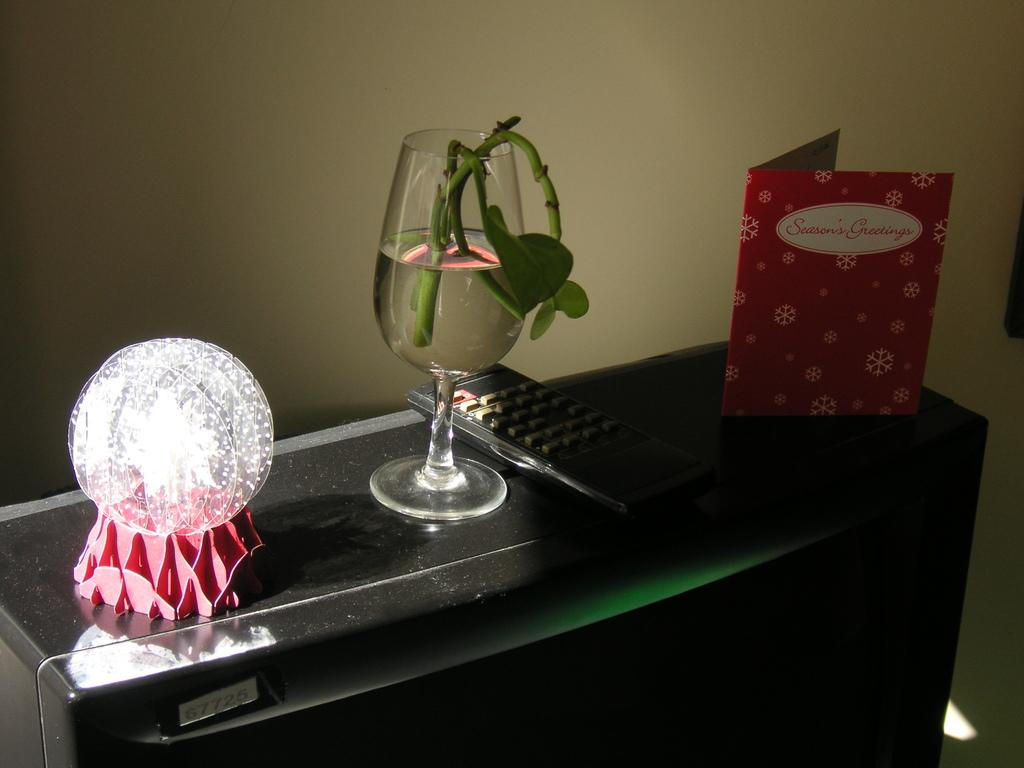What type of object is visible in the image that is typically used for drinking? There is a glass in the image. What object is visible in the image that is used for controlling electronic devices? There is a remote in the image. What type of object is visible in the image that is used for sending messages or expressing sentiments? There is a greeting card in the image. What type of object is visible in the image that emits light and has a spherical shape? There is a light ball in the image. What is the color of the object on which the items are placed? The objects are on a black color object. What is the color of the wall visible in the background of the image? The background wall is white in color. What type of vest is the brother wearing in the image during the summer? There is no brother or vest present in the image, and the image does not depict a specific season like summer. 